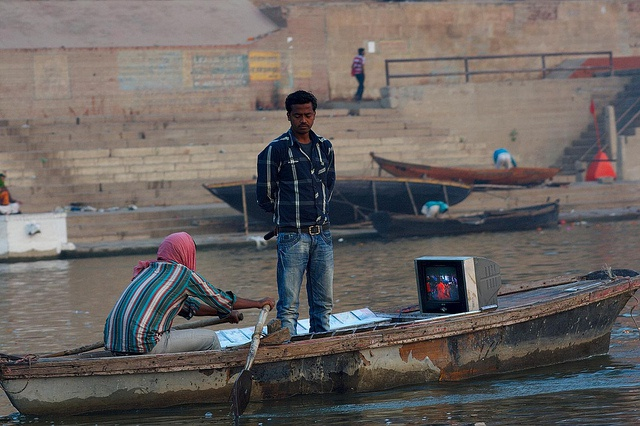Describe the objects in this image and their specific colors. I can see boat in gray, black, and maroon tones, people in gray, black, navy, and blue tones, people in gray, black, teal, and darkgray tones, boat in gray, black, navy, and blue tones, and tv in gray, black, darkgray, and navy tones in this image. 